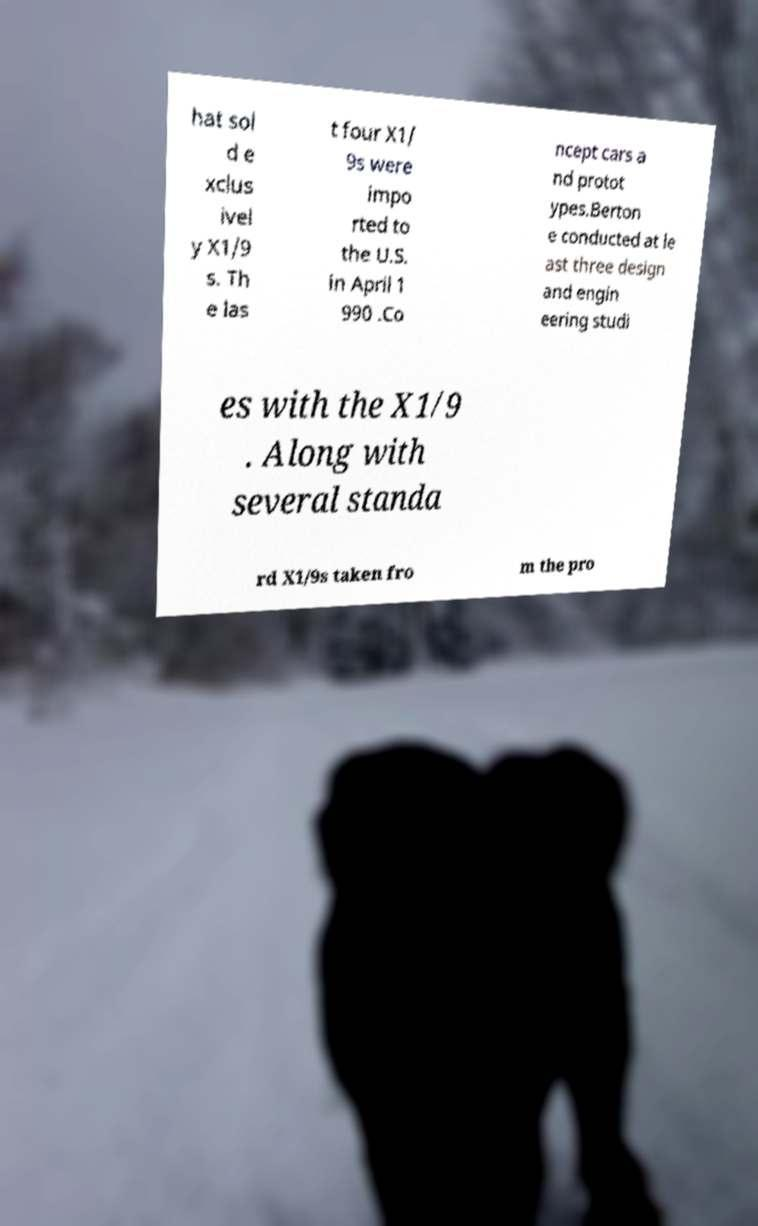Please read and relay the text visible in this image. What does it say? hat sol d e xclus ivel y X1/9 s. Th e las t four X1/ 9s were impo rted to the U.S. in April 1 990 .Co ncept cars a nd protot ypes.Berton e conducted at le ast three design and engin eering studi es with the X1/9 . Along with several standa rd X1/9s taken fro m the pro 